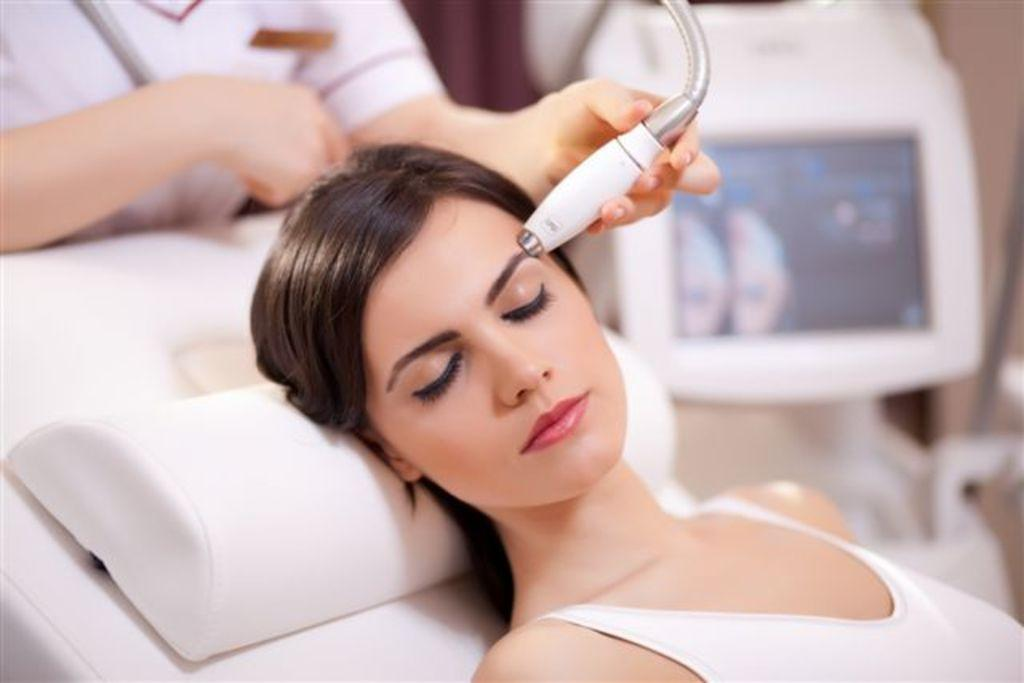Who is the main subject in the image? There is a woman in the image. What is the woman doing in the image? The woman is undergoing laser treatment. What can be seen in the background of the image? There is a monitor and another woman in the background of the image. What type of tin is being used for breakfast in the image? There is no tin or breakfast present in the image; it features a woman undergoing laser treatment. 